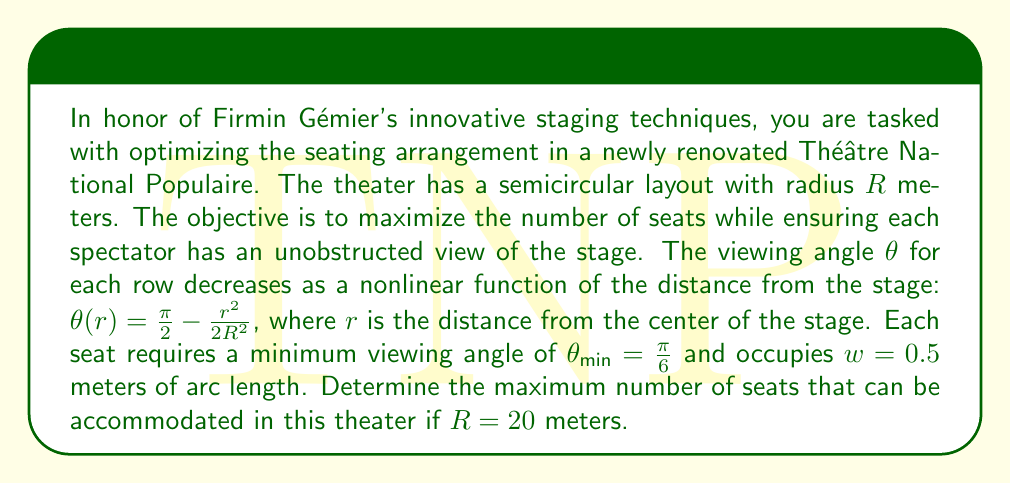Can you solve this math problem? Let's approach this problem step-by-step using nonlinear optimization techniques:

1) First, we need to find the maximum distance $r_{max}$ from the stage where the minimum viewing angle is still maintained:

   $$\frac{\pi}{2} - \frac{r_{max}^2}{2R^2} = \frac{\pi}{6}$$

2) Solving for $r_{max}$:

   $$\frac{r_{max}^2}{2R^2} = \frac{\pi}{3}$$
   $$r_{max}^2 = \frac{2\pi R^2}{3}$$
   $$r_{max} = R\sqrt{\frac{2\pi}{3}} \approx 18.26 \text{ meters}$$

3) Now, we need to determine the number of rows that can fit within this radius. Let's denote the number of rows as $n$. Each row will be placed at distance $r_i = i \cdot \Delta r$ from the center, where $i = 1, 2, ..., n$ and $\Delta r$ is the distance between rows.

4) The number of seats in each row is given by:

   $$N_i = \frac{2\pi r_i}{w}$$

5) Our objective is to maximize the total number of seats:

   $$\max \sum_{i=1}^n N_i = \max \sum_{i=1}^n \frac{2\pi r_i}{w}$$

6) Subject to the constraints:
   - $r_n \leq r_{max}$
   - $\Delta r \geq d_{min}$, where $d_{min}$ is the minimum space required between rows (let's assume $d_{min} = 0.8$ meters)

7) This is a nonlinear optimization problem. We can solve it iteratively:
   - Start with $\Delta r = d_{min} = 0.8$
   - Calculate $n = \lfloor r_{max} / \Delta r \rfloor = 22$
   - Calculate total seats: $\sum_{i=1}^{22} \frac{2\pi (i \cdot 0.8)}{0.5} \approx 4431$

8) We can optimize further by slightly increasing $\Delta r$ to use the full $r_{max}$:
   $\Delta r = r_{max} / 22 \approx 0.83$ meters

9) Recalculating the total number of seats:

   $$\sum_{i=1}^{22} \frac{2\pi (i \cdot 0.83)}{0.5} \approx 4596$$

Therefore, the maximum number of seats that can be accommodated is approximately 4596.
Answer: 4596 seats 